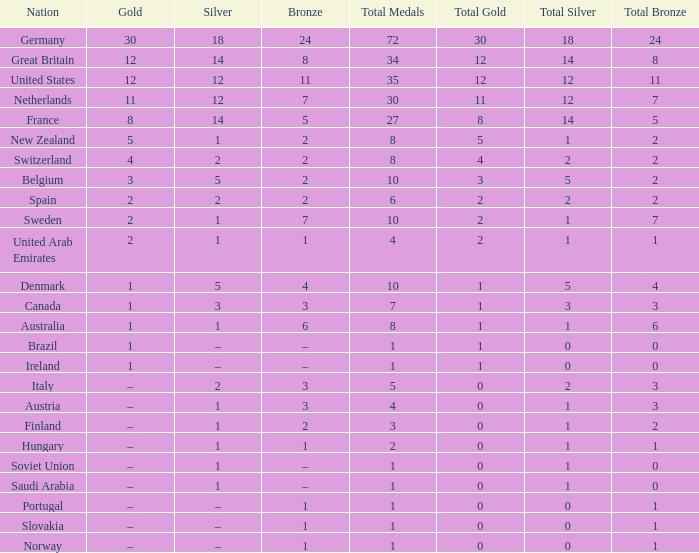What is Gold, when Bronze is 11? 12.0. 